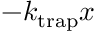Convert formula to latex. <formula><loc_0><loc_0><loc_500><loc_500>- k _ { t r a p } x</formula> 